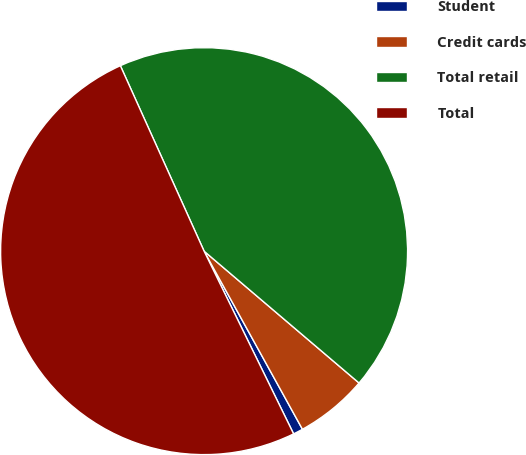Convert chart. <chart><loc_0><loc_0><loc_500><loc_500><pie_chart><fcel>Student<fcel>Credit cards<fcel>Total retail<fcel>Total<nl><fcel>0.78%<fcel>5.75%<fcel>42.97%<fcel>50.5%<nl></chart> 